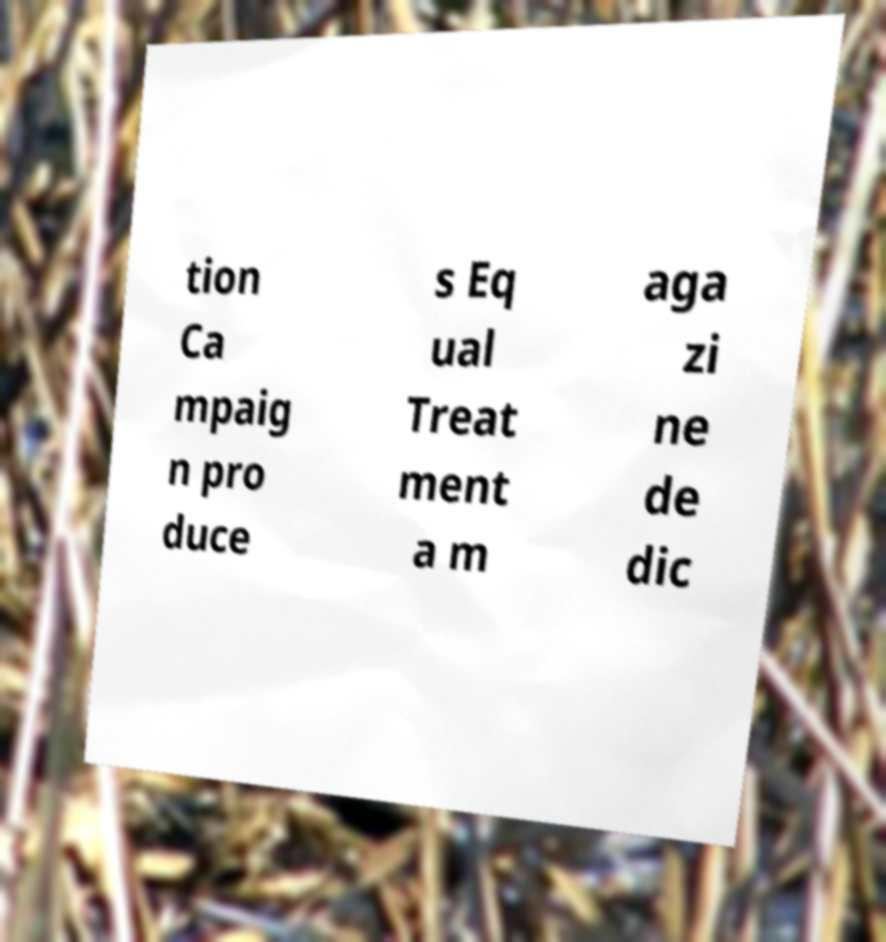Please identify and transcribe the text found in this image. tion Ca mpaig n pro duce s Eq ual Treat ment a m aga zi ne de dic 